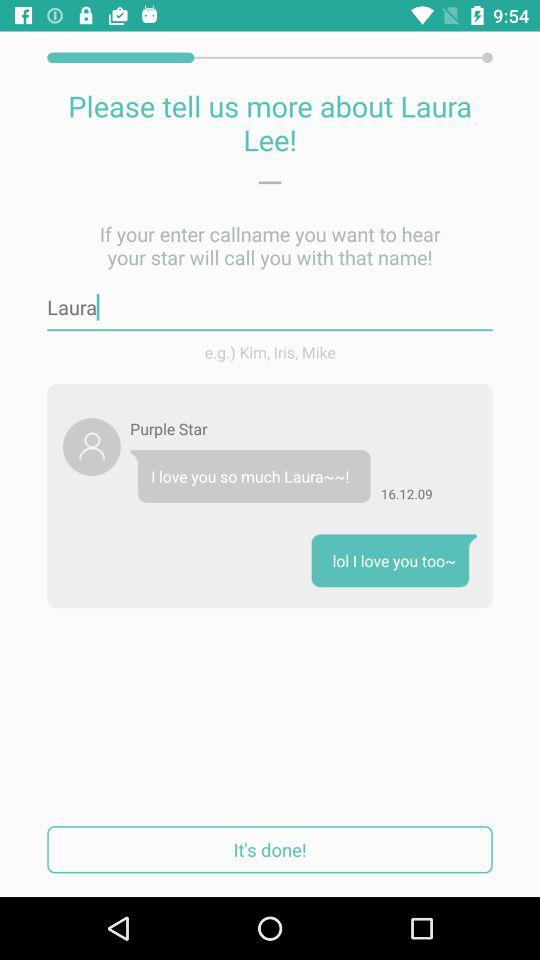What name is entered? The name is "Laura". 